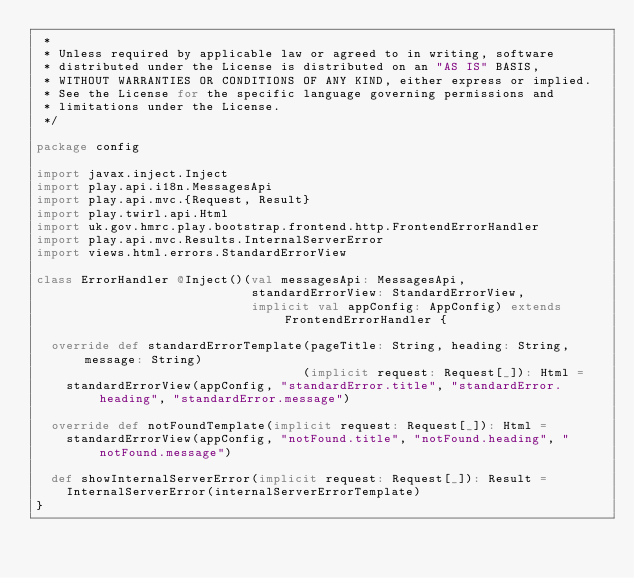<code> <loc_0><loc_0><loc_500><loc_500><_Scala_> *
 * Unless required by applicable law or agreed to in writing, software
 * distributed under the License is distributed on an "AS IS" BASIS,
 * WITHOUT WARRANTIES OR CONDITIONS OF ANY KIND, either express or implied.
 * See the License for the specific language governing permissions and
 * limitations under the License.
 */

package config

import javax.inject.Inject
import play.api.i18n.MessagesApi
import play.api.mvc.{Request, Result}
import play.twirl.api.Html
import uk.gov.hmrc.play.bootstrap.frontend.http.FrontendErrorHandler
import play.api.mvc.Results.InternalServerError
import views.html.errors.StandardErrorView

class ErrorHandler @Inject()(val messagesApi: MessagesApi,
                             standardErrorView: StandardErrorView,
                             implicit val appConfig: AppConfig) extends FrontendErrorHandler {

  override def standardErrorTemplate(pageTitle: String, heading: String, message: String)
                                    (implicit request: Request[_]): Html =
    standardErrorView(appConfig, "standardError.title", "standardError.heading", "standardError.message")

  override def notFoundTemplate(implicit request: Request[_]): Html =
    standardErrorView(appConfig, "notFound.title", "notFound.heading", "notFound.message")

  def showInternalServerError(implicit request: Request[_]): Result =
    InternalServerError(internalServerErrorTemplate)
}
</code> 